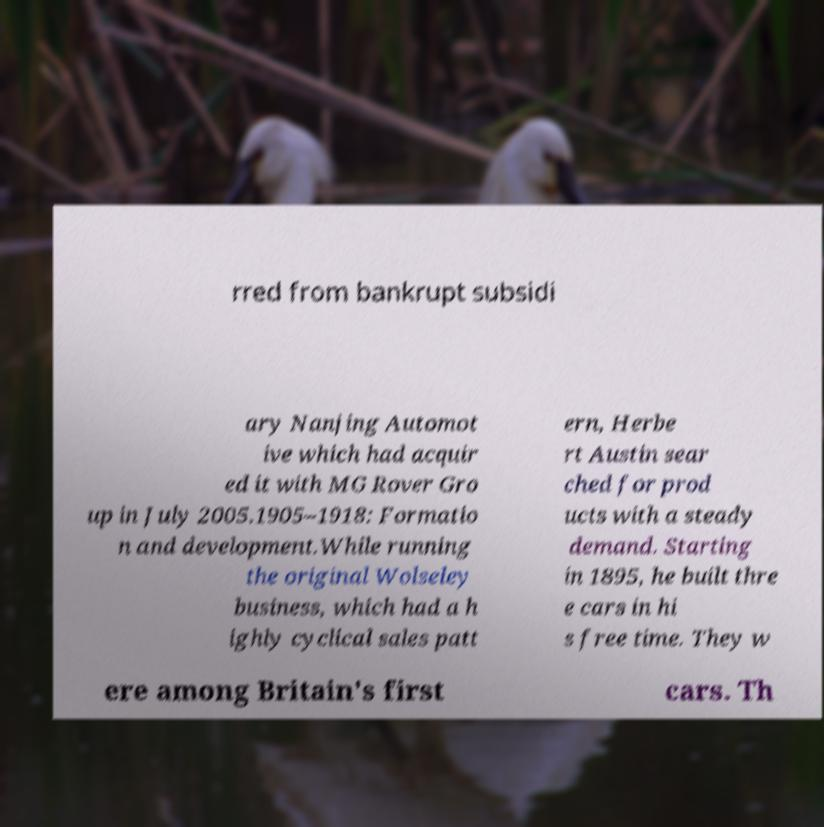Could you extract and type out the text from this image? rred from bankrupt subsidi ary Nanjing Automot ive which had acquir ed it with MG Rover Gro up in July 2005.1905–1918: Formatio n and development.While running the original Wolseley business, which had a h ighly cyclical sales patt ern, Herbe rt Austin sear ched for prod ucts with a steady demand. Starting in 1895, he built thre e cars in hi s free time. They w ere among Britain's first cars. Th 